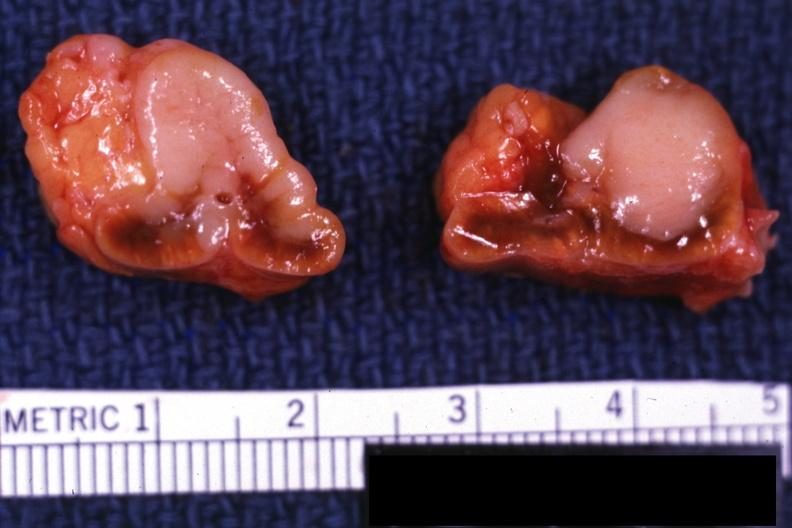s infant body present?
Answer the question using a single word or phrase. No 